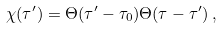<formula> <loc_0><loc_0><loc_500><loc_500>\chi ( \tau ^ { \prime } ) = \Theta ( \tau ^ { \prime } - \tau _ { 0 } ) \Theta ( \tau - \tau ^ { \prime } ) \, ,</formula> 